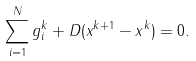<formula> <loc_0><loc_0><loc_500><loc_500>\sum _ { i = 1 } ^ { N } g ^ { k } _ { i } + D ( x ^ { k + 1 } - x ^ { k } ) = 0 .</formula> 